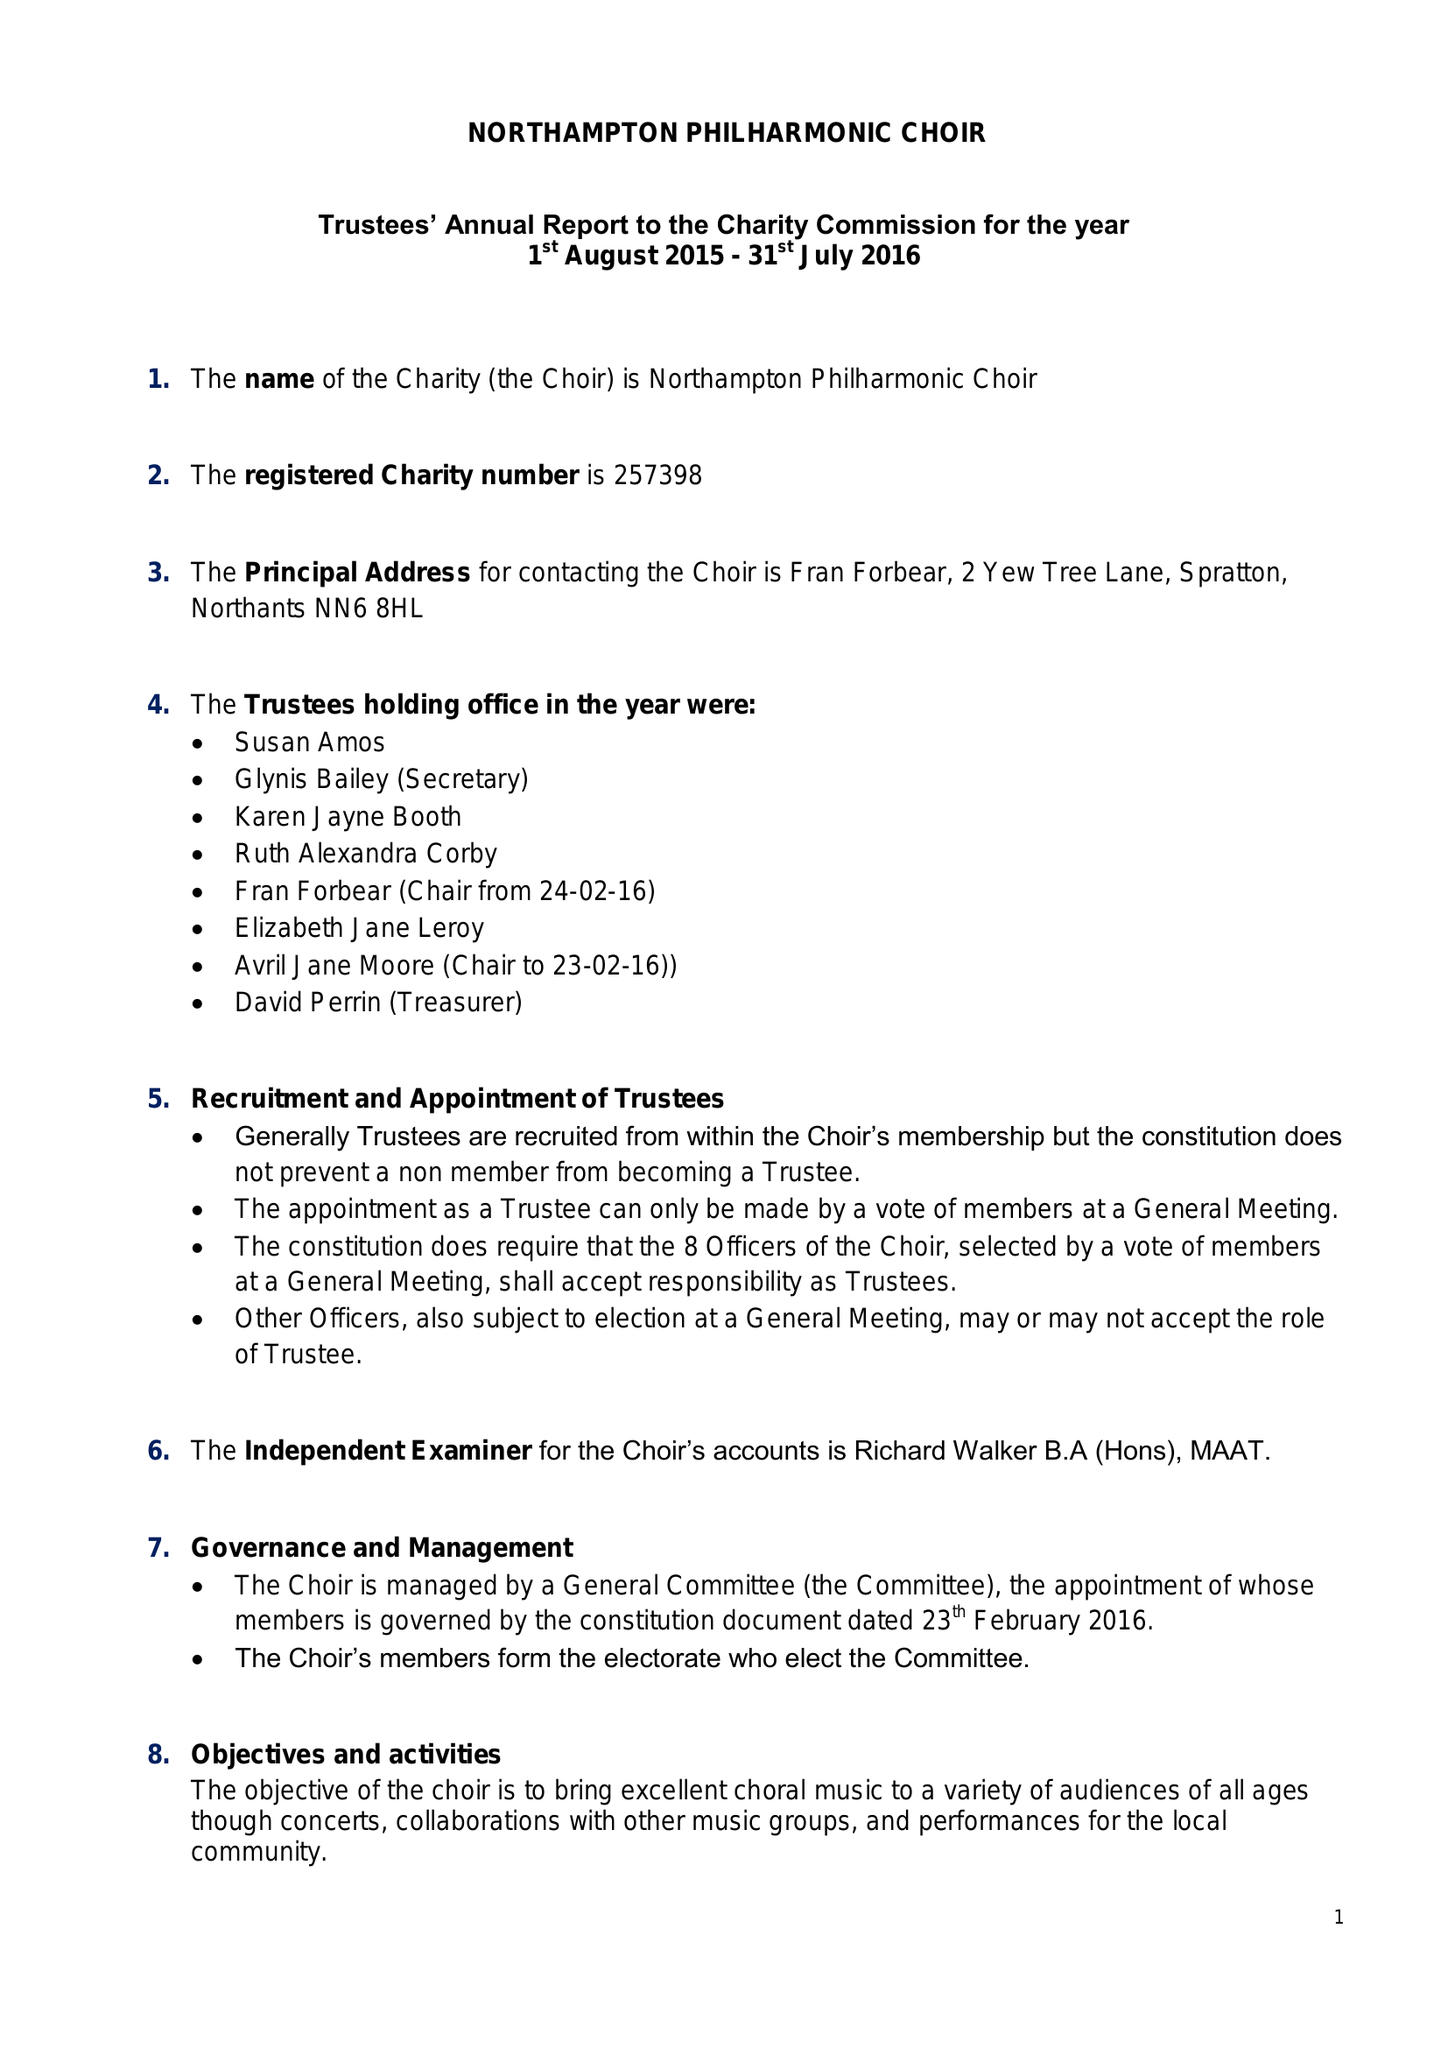What is the value for the spending_annually_in_british_pounds?
Answer the question using a single word or phrase. 24788.00 